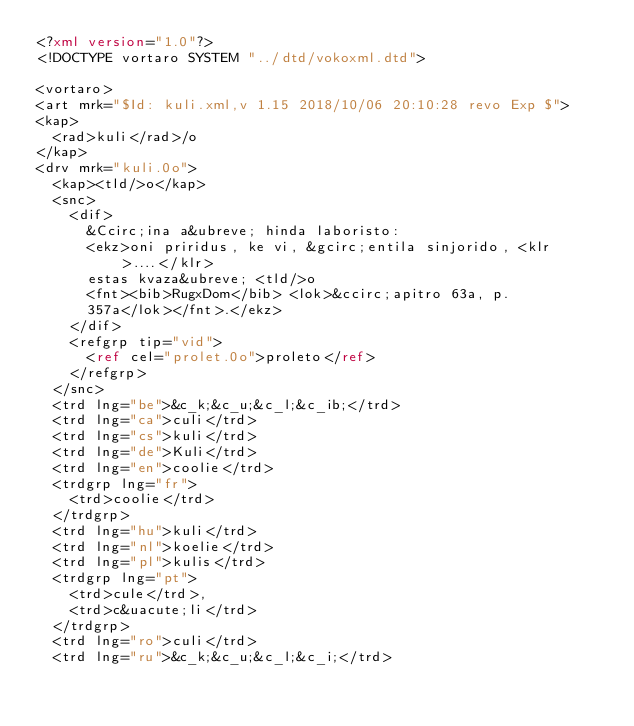<code> <loc_0><loc_0><loc_500><loc_500><_XML_><?xml version="1.0"?>
<!DOCTYPE vortaro SYSTEM "../dtd/vokoxml.dtd">

<vortaro>
<art mrk="$Id: kuli.xml,v 1.15 2018/10/06 20:10:28 revo Exp $">
<kap>
  <rad>kuli</rad>/o
</kap>
<drv mrk="kuli.0o">
  <kap><tld/>o</kap>
  <snc>
    <dif>
      &Ccirc;ina a&ubreve; hinda laboristo:
      <ekz>oni priridus, ke vi, &gcirc;entila sinjorido, <klr>....</klr>
      estas kvaza&ubreve; <tld/>o
      <fnt><bib>RugxDom</bib> <lok>&ccirc;apitro 63a, p.
      357a</lok></fnt>.</ekz>
    </dif>
    <refgrp tip="vid">
      <ref cel="prolet.0o">proleto</ref>
    </refgrp>
  </snc>
  <trd lng="be">&c_k;&c_u;&c_l;&c_ib;</trd>
  <trd lng="ca">culi</trd>
  <trd lng="cs">kuli</trd>
  <trd lng="de">Kuli</trd>
  <trd lng="en">coolie</trd>
  <trdgrp lng="fr">
    <trd>coolie</trd>
  </trdgrp>
  <trd lng="hu">kuli</trd>
  <trd lng="nl">koelie</trd>
  <trd lng="pl">kulis</trd>
  <trdgrp lng="pt">
    <trd>cule</trd>,
    <trd>c&uacute;li</trd>
  </trdgrp>
  <trd lng="ro">culi</trd>
  <trd lng="ru">&c_k;&c_u;&c_l;&c_i;</trd></code> 